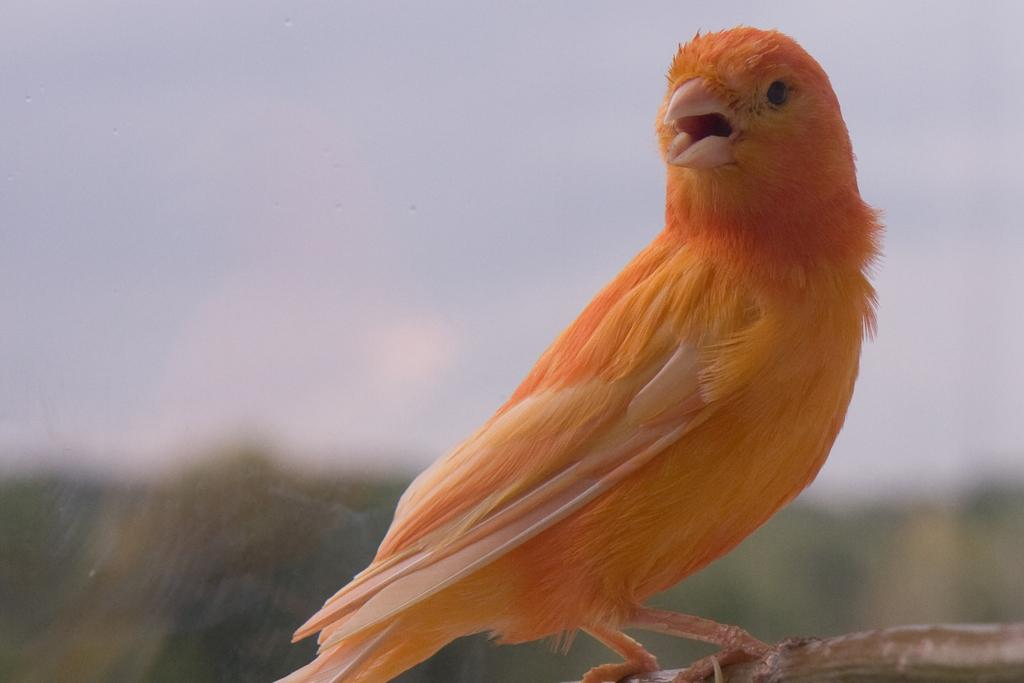What type of animal is in the image? There is a bird in the image. Where is the bird located? The bird is on a system. Can you describe the background of the image? The background of the image is blurred. What type of treatment is the tiger receiving in the image? There is no tiger present in the image, so it is not possible to discuss any treatment. 